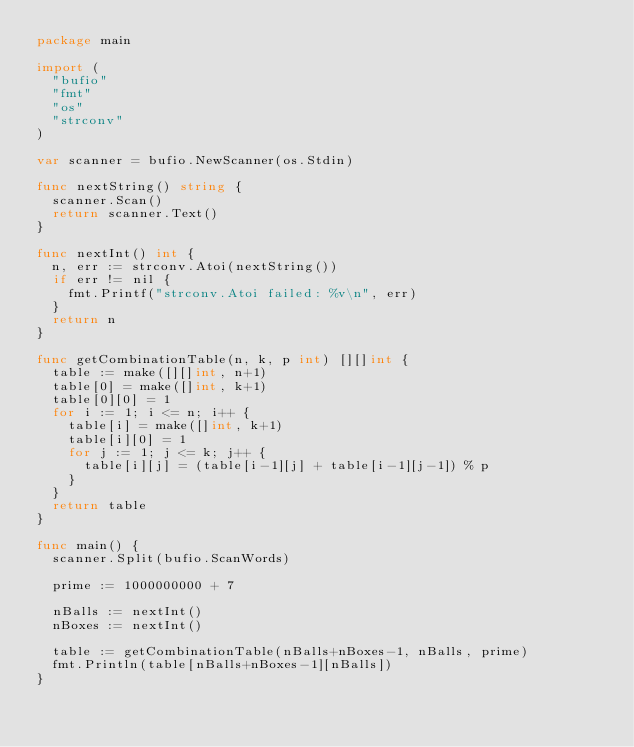Convert code to text. <code><loc_0><loc_0><loc_500><loc_500><_Go_>package main

import (
	"bufio"
	"fmt"
	"os"
	"strconv"
)

var scanner = bufio.NewScanner(os.Stdin)

func nextString() string {
	scanner.Scan()
	return scanner.Text()
}

func nextInt() int {
	n, err := strconv.Atoi(nextString())
	if err != nil {
		fmt.Printf("strconv.Atoi failed: %v\n", err)
	}
	return n
}

func getCombinationTable(n, k, p int) [][]int {
	table := make([][]int, n+1)
	table[0] = make([]int, k+1)
	table[0][0] = 1
	for i := 1; i <= n; i++ {
		table[i] = make([]int, k+1)
		table[i][0] = 1
		for j := 1; j <= k; j++ {
			table[i][j] = (table[i-1][j] + table[i-1][j-1]) % p
		}
	}
	return table
}

func main() {
	scanner.Split(bufio.ScanWords)

	prime := 1000000000 + 7

	nBalls := nextInt()
	nBoxes := nextInt()

	table := getCombinationTable(nBalls+nBoxes-1, nBalls, prime)
	fmt.Println(table[nBalls+nBoxes-1][nBalls])
}

</code> 